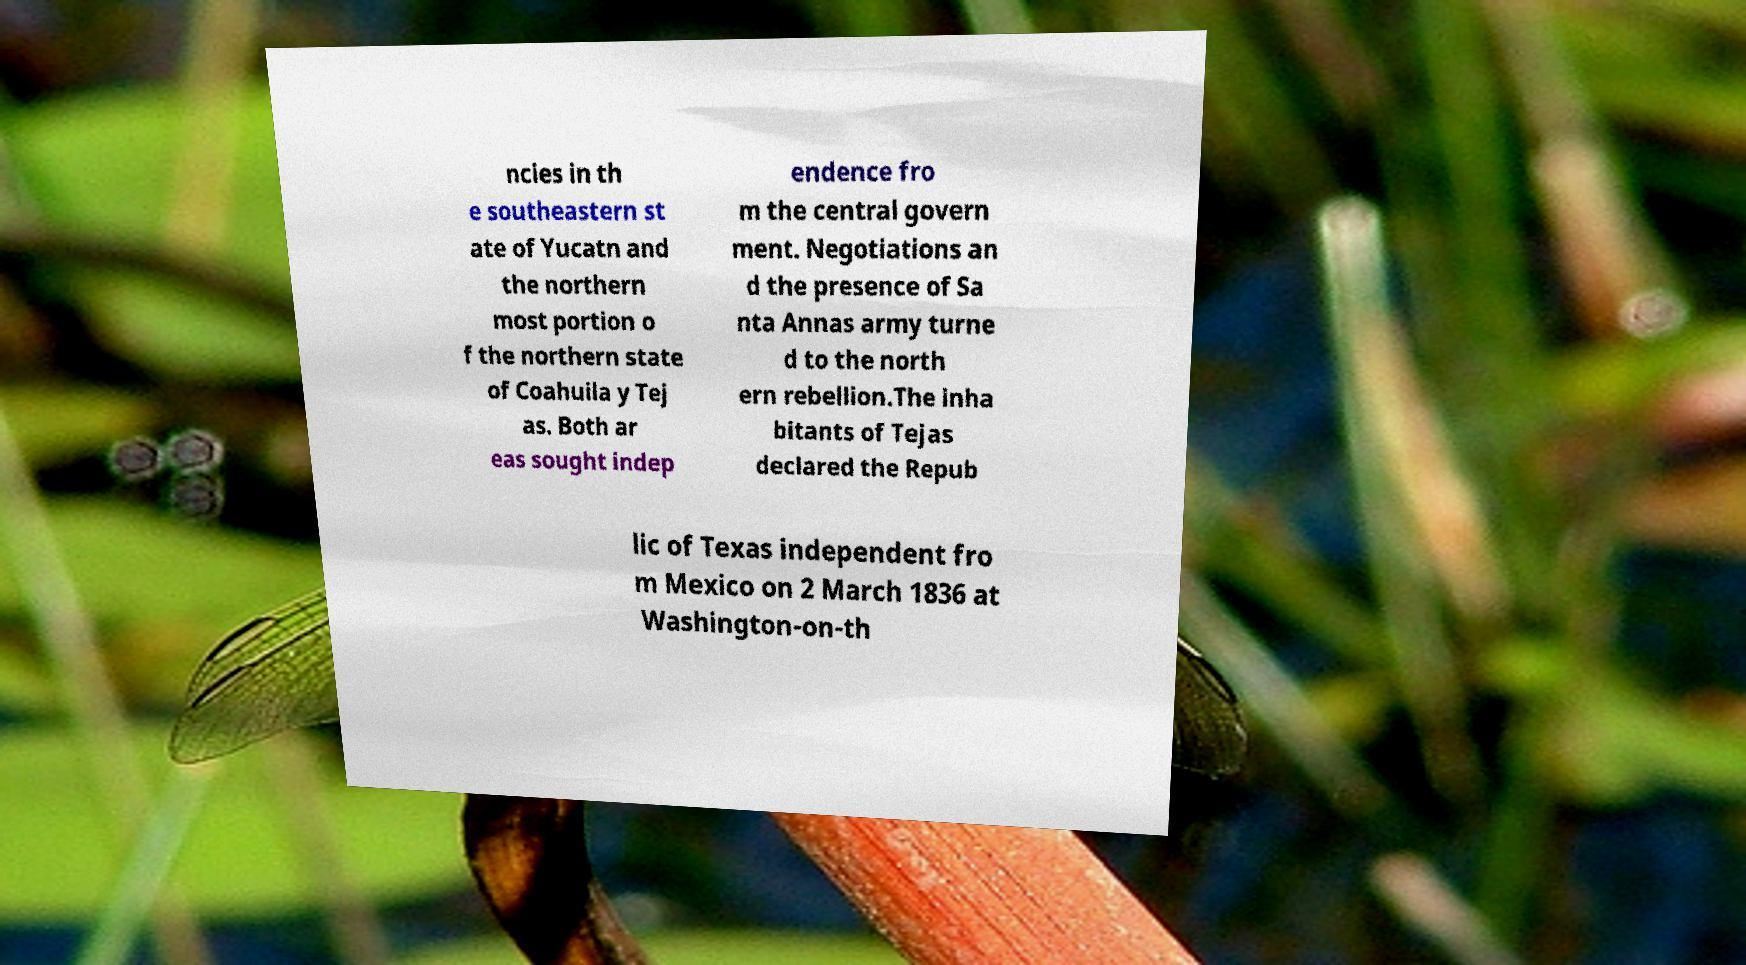What messages or text are displayed in this image? I need them in a readable, typed format. ncies in th e southeastern st ate of Yucatn and the northern most portion o f the northern state of Coahuila y Tej as. Both ar eas sought indep endence fro m the central govern ment. Negotiations an d the presence of Sa nta Annas army turne d to the north ern rebellion.The inha bitants of Tejas declared the Repub lic of Texas independent fro m Mexico on 2 March 1836 at Washington-on-th 